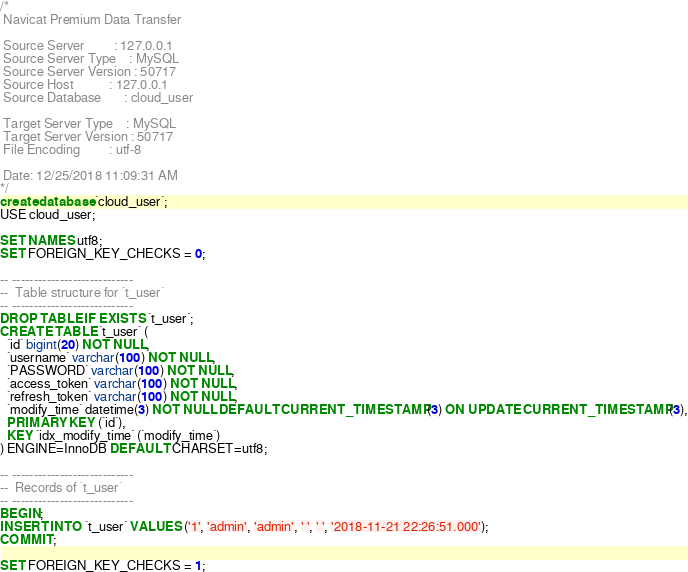<code> <loc_0><loc_0><loc_500><loc_500><_SQL_>/*
 Navicat Premium Data Transfer

 Source Server         : 127.0.0.1
 Source Server Type    : MySQL
 Source Server Version : 50717
 Source Host           : 127.0.0.1
 Source Database       : cloud_user

 Target Server Type    : MySQL
 Target Server Version : 50717
 File Encoding         : utf-8

 Date: 12/25/2018 11:09:31 AM
*/
create database `cloud_user`;
USE cloud_user;

SET NAMES utf8;
SET FOREIGN_KEY_CHECKS = 0;

-- ----------------------------
--  Table structure for `t_user`
-- ----------------------------
DROP TABLE IF EXISTS `t_user`;
CREATE TABLE `t_user` (
  `id` bigint(20) NOT NULL,
  `username` varchar(100) NOT NULL,
  `PASSWORD` varchar(100) NOT NULL,
  `access_token` varchar(100) NOT NULL,
  `refresh_token` varchar(100) NOT NULL,
  `modify_time` datetime(3) NOT NULL DEFAULT CURRENT_TIMESTAMP(3) ON UPDATE CURRENT_TIMESTAMP(3),
  PRIMARY KEY (`id`),
  KEY `idx_modify_time` (`modify_time`)
) ENGINE=InnoDB DEFAULT CHARSET=utf8;

-- ----------------------------
--  Records of `t_user`
-- ----------------------------
BEGIN;
INSERT INTO `t_user` VALUES ('1', 'admin', 'admin', ' ', ' ', '2018-11-21 22:26:51.000');
COMMIT;

SET FOREIGN_KEY_CHECKS = 1;
</code> 